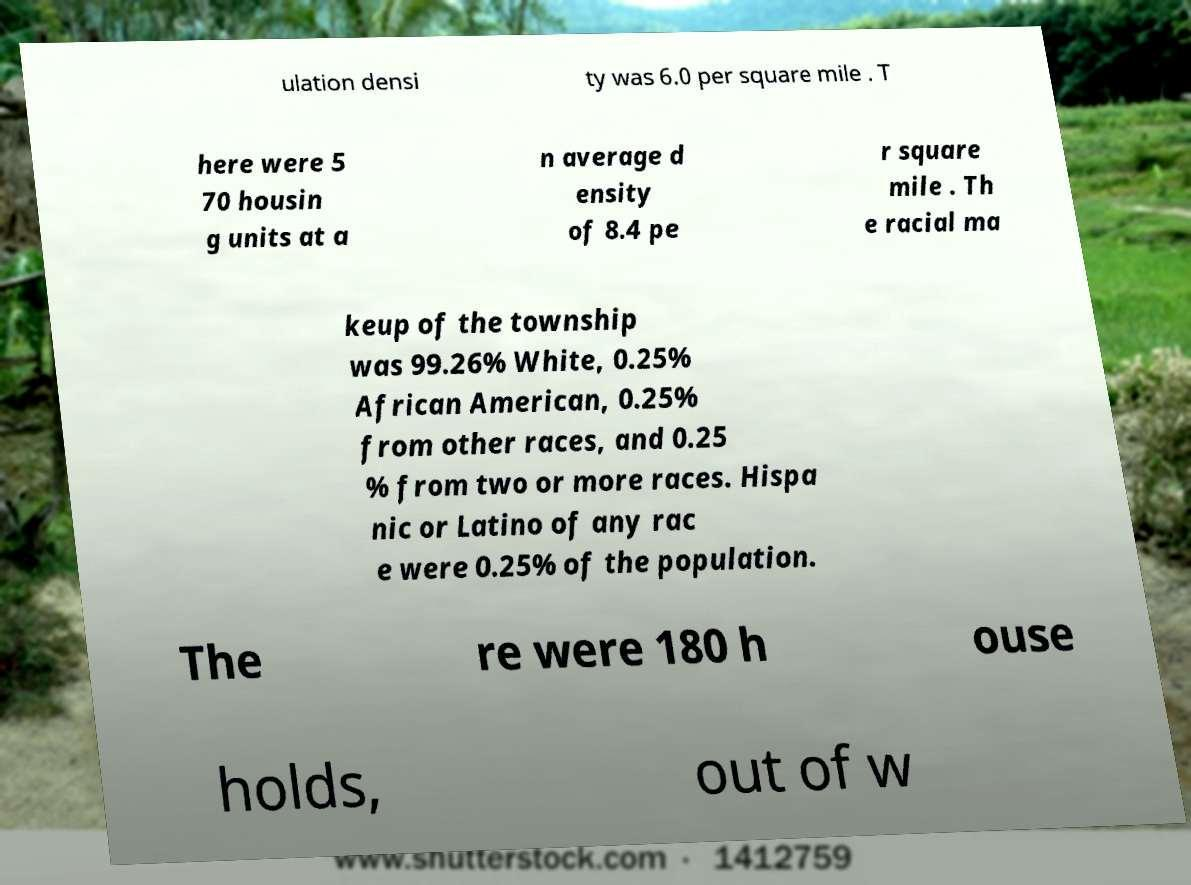Could you assist in decoding the text presented in this image and type it out clearly? ulation densi ty was 6.0 per square mile . T here were 5 70 housin g units at a n average d ensity of 8.4 pe r square mile . Th e racial ma keup of the township was 99.26% White, 0.25% African American, 0.25% from other races, and 0.25 % from two or more races. Hispa nic or Latino of any rac e were 0.25% of the population. The re were 180 h ouse holds, out of w 